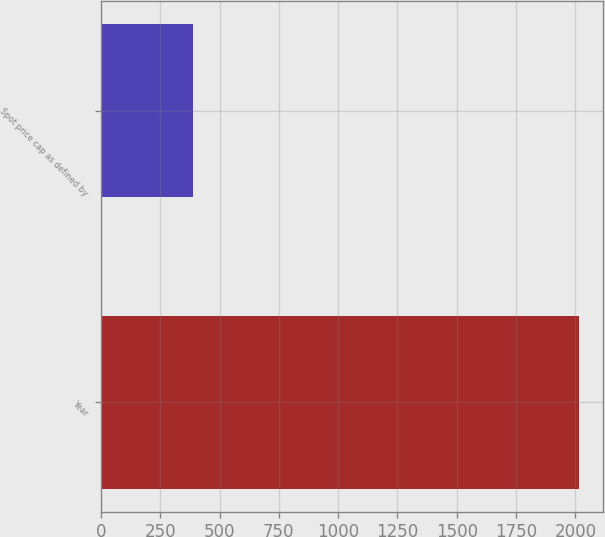Convert chart to OTSL. <chart><loc_0><loc_0><loc_500><loc_500><bar_chart><fcel>Year<fcel>Spot price cap as defined by<nl><fcel>2015<fcel>388<nl></chart> 